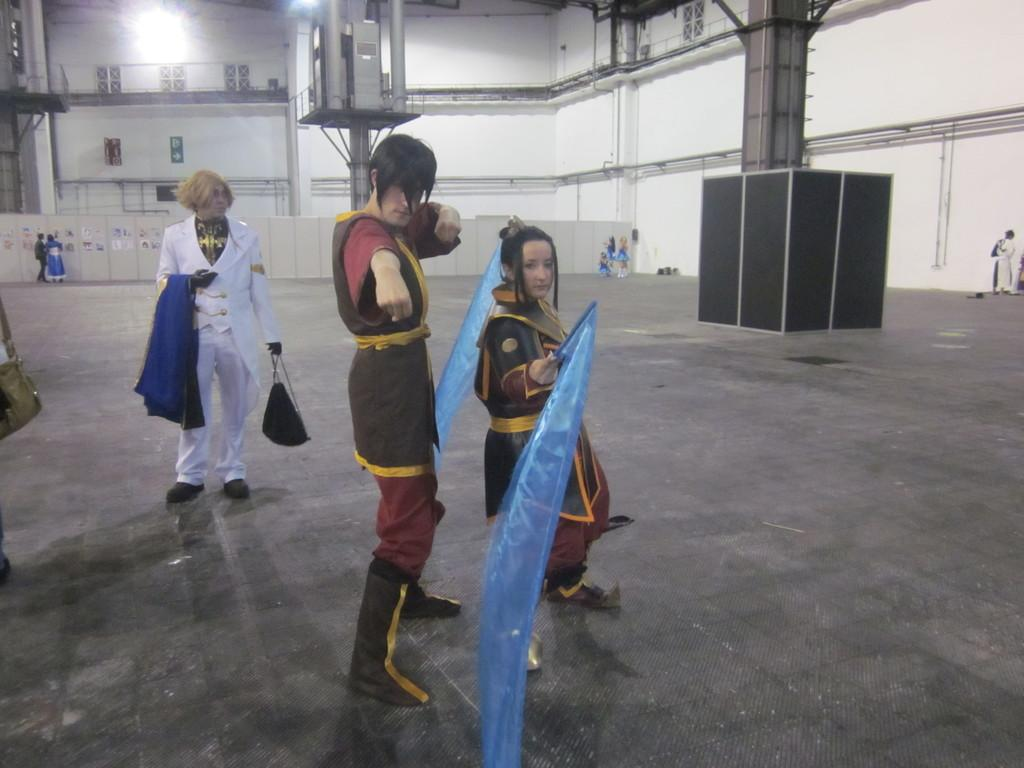How many people are present in the image? There are three people standing in the image. What are two of the people doing in the image? Two of the people are holding objects. Can you describe the background of the image? There are people, walls, and objects visible in the background of the image. What type of punishment is being administered to the kittens in the image? There are no kittens present in the image, so no punishment is being administered. 